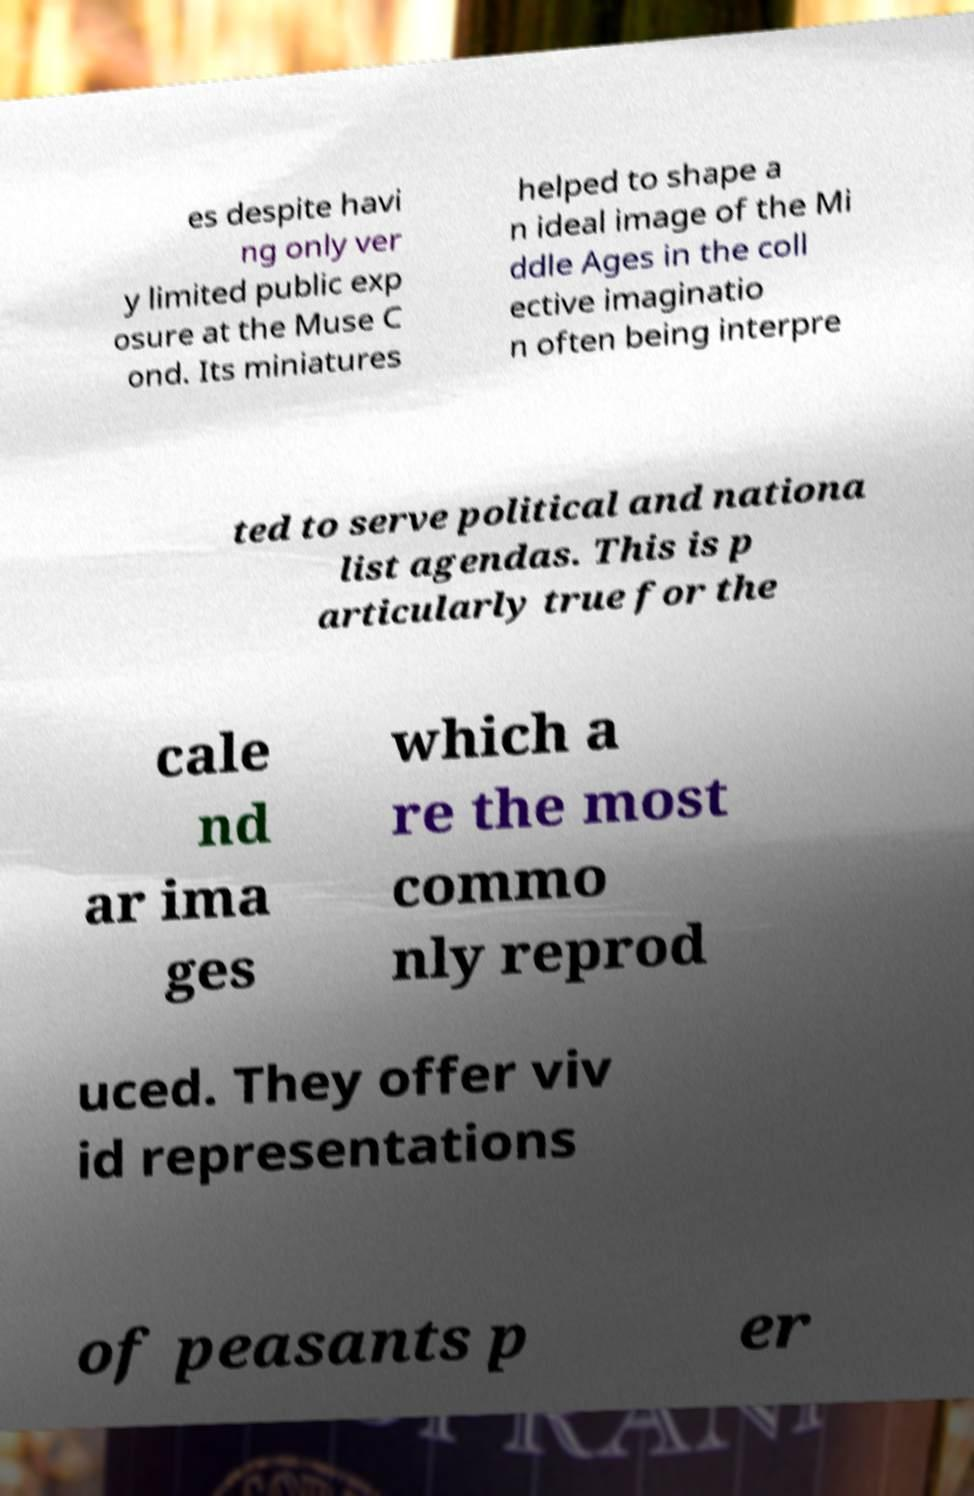Can you read and provide the text displayed in the image?This photo seems to have some interesting text. Can you extract and type it out for me? es despite havi ng only ver y limited public exp osure at the Muse C ond. Its miniatures helped to shape a n ideal image of the Mi ddle Ages in the coll ective imaginatio n often being interpre ted to serve political and nationa list agendas. This is p articularly true for the cale nd ar ima ges which a re the most commo nly reprod uced. They offer viv id representations of peasants p er 